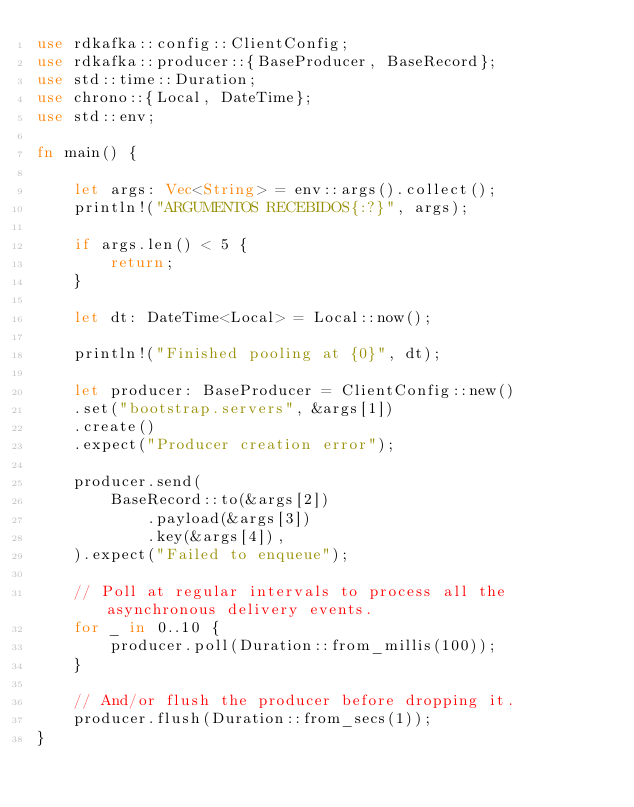Convert code to text. <code><loc_0><loc_0><loc_500><loc_500><_Rust_>use rdkafka::config::ClientConfig;
use rdkafka::producer::{BaseProducer, BaseRecord};
use std::time::Duration;
use chrono::{Local, DateTime};
use std::env;

fn main() {

    let args: Vec<String> = env::args().collect();
    println!("ARGUMENTOS RECEBIDOS{:?}", args);

    if args.len() < 5 {
        return;
    }

    let dt: DateTime<Local> = Local::now();

    println!("Finished pooling at {0}", dt);    

    let producer: BaseProducer = ClientConfig::new()    
    .set("bootstrap.servers", &args[1])
    .create()
    .expect("Producer creation error");

    producer.send(
        BaseRecord::to(&args[2])
            .payload(&args[3])
            .key(&args[4]),
    ).expect("Failed to enqueue");    

    // Poll at regular intervals to process all the asynchronous delivery events.
    for _ in 0..10 {
        producer.poll(Duration::from_millis(100));
    }

    // And/or flush the producer before dropping it.
    producer.flush(Duration::from_secs(1));
}</code> 